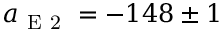<formula> <loc_0><loc_0><loc_500><loc_500>a _ { E 2 } = - 1 4 8 \pm 1</formula> 